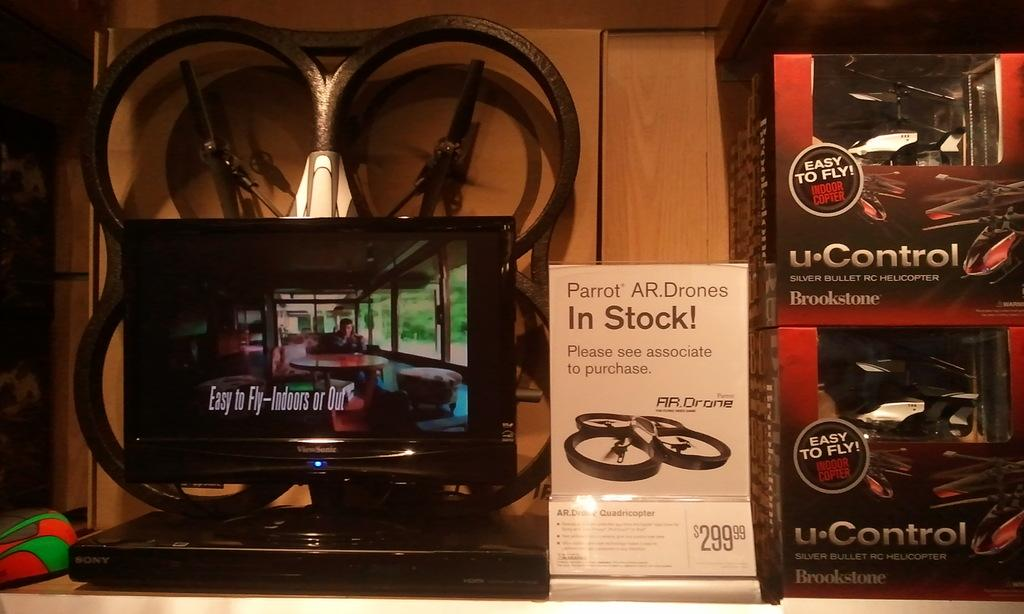Provide a one-sentence caption for the provided image. A shelf has a portable DVD player on it and drones with a sign that says Parrot AR Drones In Stock. 